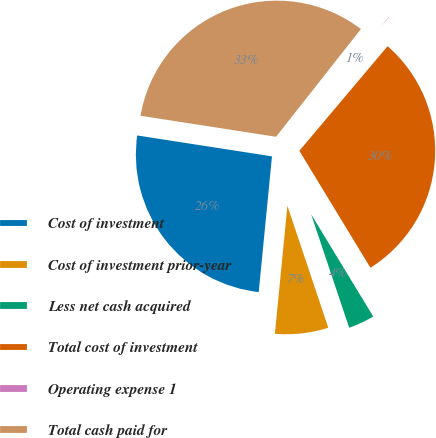Convert chart. <chart><loc_0><loc_0><loc_500><loc_500><pie_chart><fcel>Cost of investment<fcel>Cost of investment prior-year<fcel>Less net cash acquired<fcel>Total cost of investment<fcel>Operating expense 1<fcel>Total cash paid for<nl><fcel>25.9%<fcel>6.7%<fcel>3.54%<fcel>30.16%<fcel>0.53%<fcel>33.17%<nl></chart> 